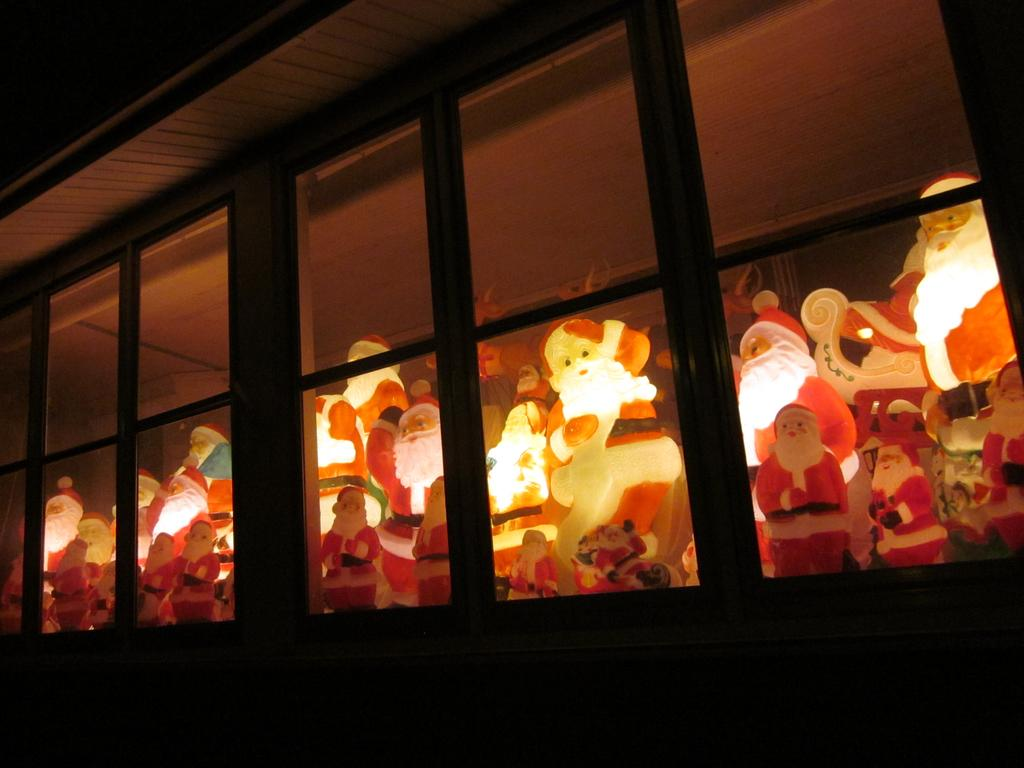What can be seen in the image? There is a window in the image, and inside the window, there are many dolls of Santa Claus. Can you describe the objects inside the window? The objects inside the window are dolls of Santa Claus. What town is mentioned in the image? There is no town mentioned in the image; it only features a window with Santa Claus dolls. 